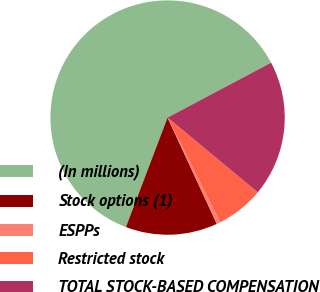Convert chart to OTSL. <chart><loc_0><loc_0><loc_500><loc_500><pie_chart><fcel>(In millions)<fcel>Stock options (1)<fcel>ESPPs<fcel>Restricted stock<fcel>TOTAL STOCK-BASED COMPENSATION<nl><fcel>61.46%<fcel>12.68%<fcel>0.49%<fcel>6.59%<fcel>18.78%<nl></chart> 